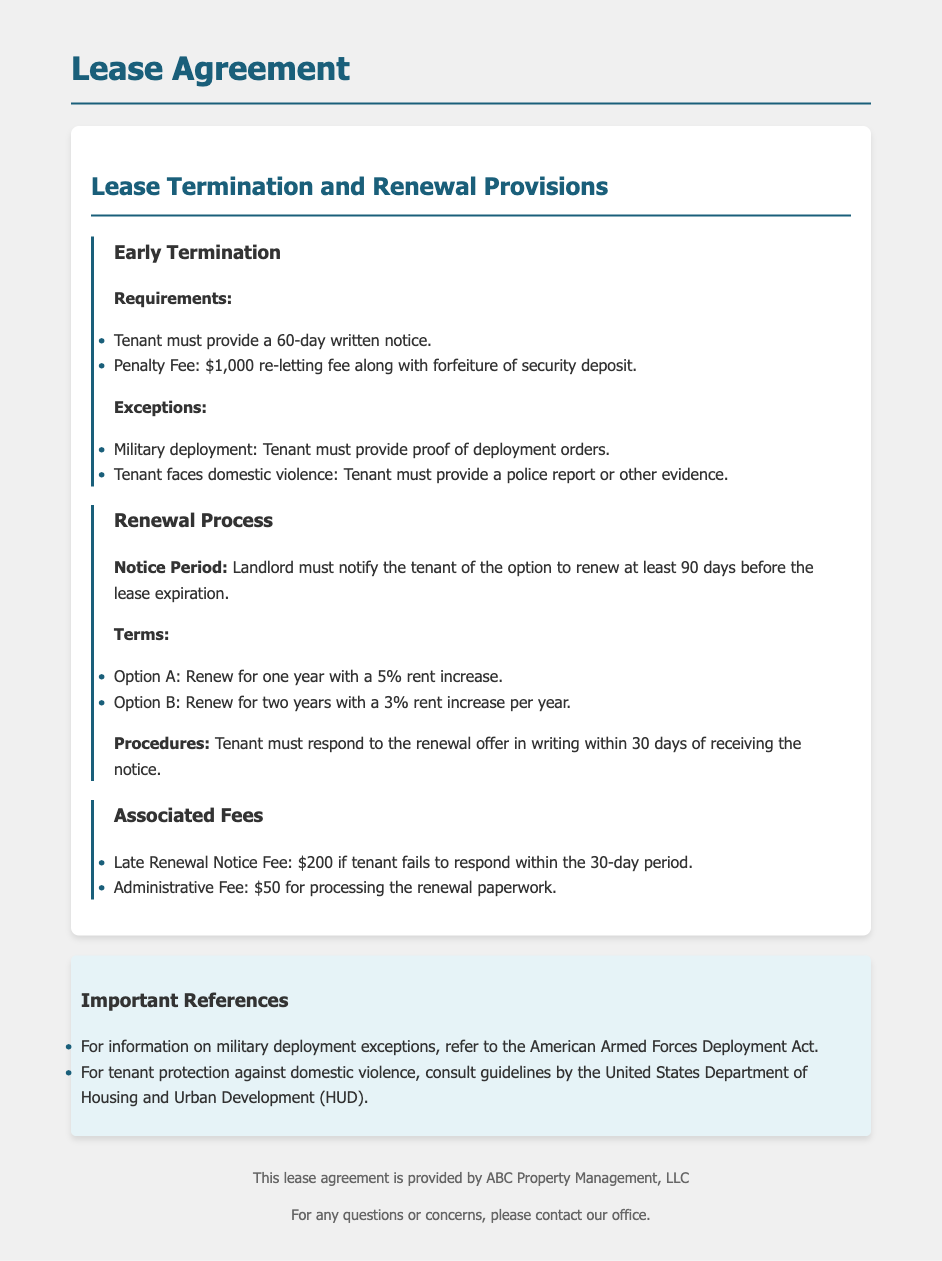What is the notice period for early termination? The notice period for early termination is specified in the early termination section.
Answer: 60-day written notice What is the penalty fee for early termination? The penalty fee is stated under the early termination requirements section.
Answer: $1,000 re-letting fee What are the conditions for exceptions to early termination? The conditions for exceptions are listed and include military deployment and domestic violence.
Answer: Military deployment, domestic violence How far in advance must a landlord notify the tenant for lease renewal? This information can be found in the renewal process section, specifically regarding the landlord's obligations.
Answer: 90 days What options are available for renewal terms? The options for renewal terms are provided in the renewal process section.
Answer: Option A: 5% increase, Option B: 3% increase per year What is the late renewal notice fee? The late renewal notice fee is explained under associated fees.
Answer: $200 What is the administrative fee for processing renewal paperwork? Information about administrative fees is included under fees associated with the renewal process.
Answer: $50 Within what time frame must the tenant respond to the renewal offer? The timeframe for tenant response is mentioned in the procedures section of the renewal process.
Answer: 30 days What must a tenant provide to prove military deployment? This requirement is outlined in the exceptions for early termination.
Answer: Proof of deployment orders 